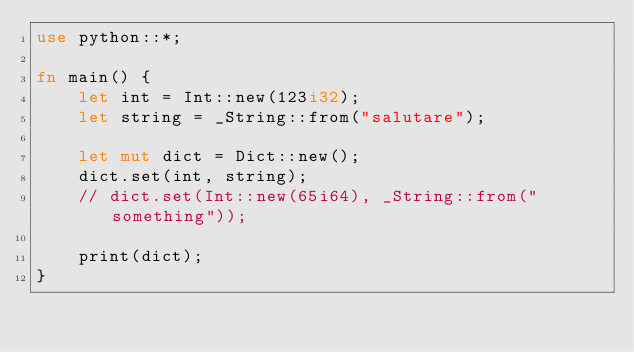<code> <loc_0><loc_0><loc_500><loc_500><_Rust_>use python::*;

fn main() {
    let int = Int::new(123i32);
    let string = _String::from("salutare");

    let mut dict = Dict::new();
    dict.set(int, string);
    // dict.set(Int::new(65i64), _String::from("something"));

    print(dict);
}
</code> 